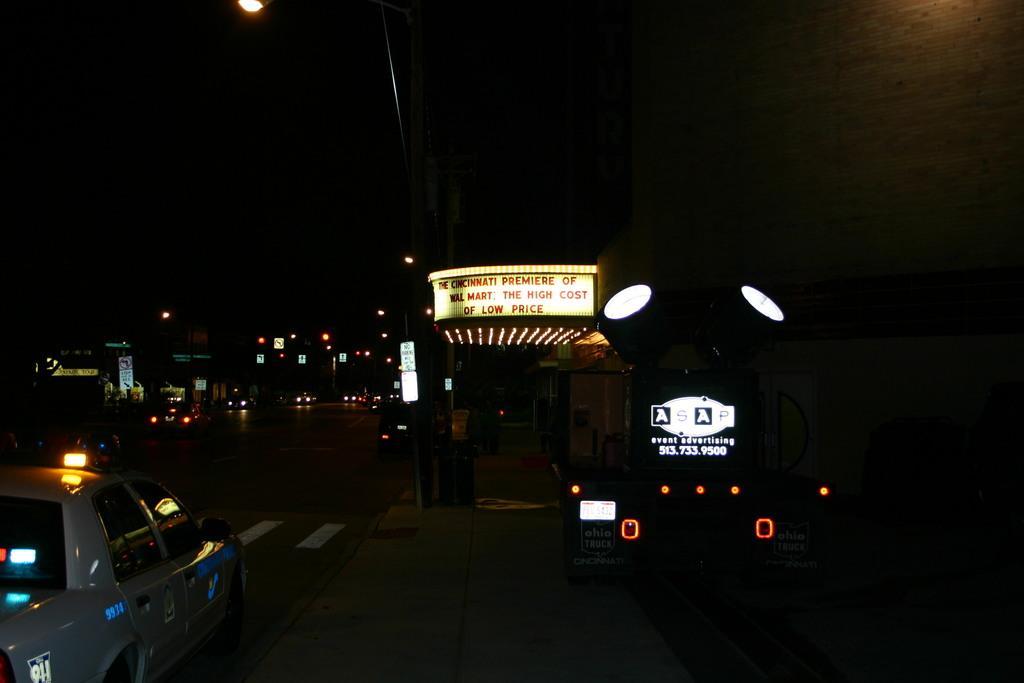Can you describe this image briefly? There are few vehicles on the road in the left corner and there is a building which has few lights and something written on it in the right corner. 